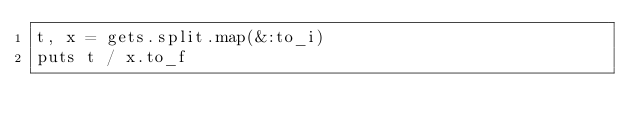<code> <loc_0><loc_0><loc_500><loc_500><_Ruby_>t, x = gets.split.map(&:to_i)
puts t / x.to_f
</code> 